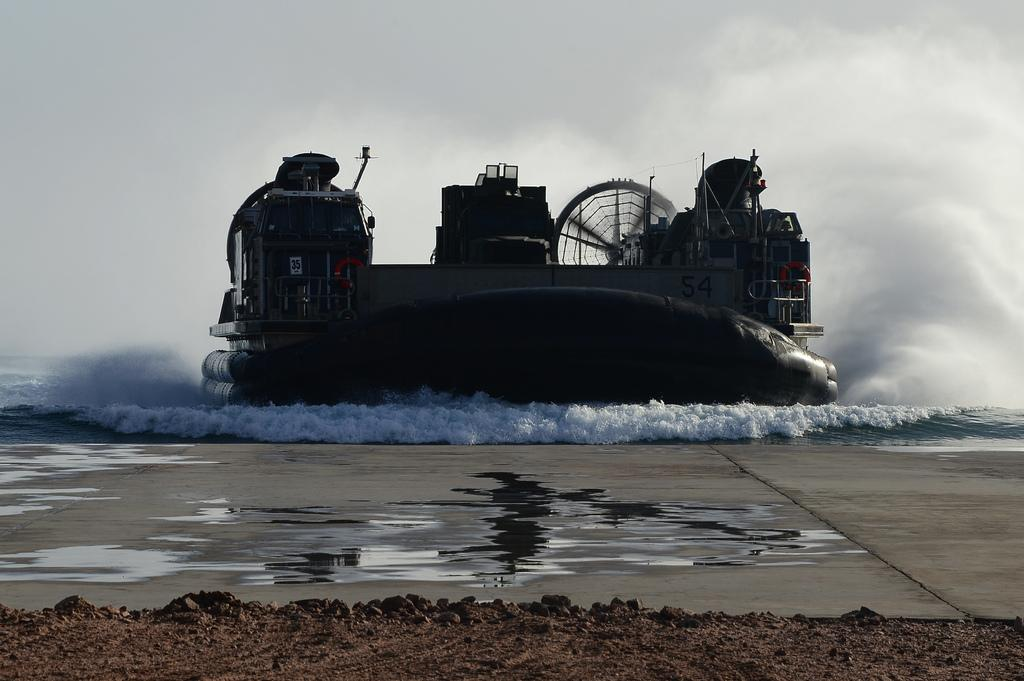What type of vehicle is in the water in the image? There is a hover boat in the boat in the water in the image. What can be seen below the hover boat? The floor is visible in the image. What type of natural elements are present in the image? There are stones in the image. What is visible above the hover boat? The sky is visible in the image. What is the weather condition in the image? The sky appears to be cloudy in the image. What type of cake is being rolled out on the floor in the image? There is no cake or rolling out of cake present in the image. 